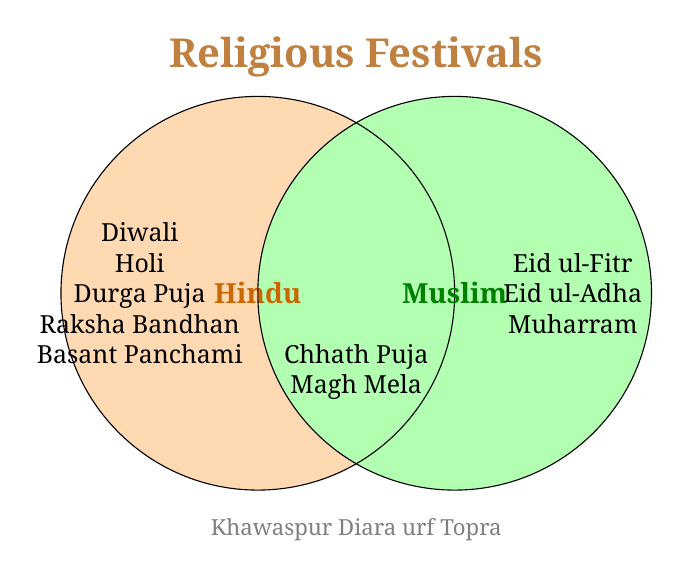What are the common religious festivals celebrated in the community? The common festivals appear in the area where the two circles intersect. This section contains "Chhath Puja" and "Magh Mela."
Answer: Chhath Puja, Magh Mela How many festivals are celebrated only by Hindus? The Hindu-only festivals are listed in the orange circle on the left. These are "Diwali," "Holi," "Durga Puja," "Raksha Bandhan," and "Basant Panchami."
Answer: 5 Which religious group celebrates "Eid ul-Fitr"? "Eid ul-Fitr" is listed in the green circle, which is attributed to Muslims.
Answer: Muslims Is "Raksha Bandhan" a common festival between Hindus and Muslims? "Raksha Bandhan" is located in the orange circle specific to Hindus and not in the overlapping area.
Answer: No How many festivals are celebrated exclusively by Muslims? The Muslim-only festivals are listed in the green circle on the right. These are "Eid ul-Fitr," "Eid ul-Adha," and "Muharram."
Answer: 3 Which religious festivals are unique and not shared by any other group? Unique festivals are those listed in either the Hindu or Muslim circles but not in the overlapping section. Hindu: "Diwali," "Holi," "Durga Puja," "Raksha Bandhan," "Basant Panchami." Muslim: "Eid ul-Fitr," "Eid ul-Adha," "Muharram."
Answer: Diwali, Holi, Durga Puja, Raksha Bandhan, Basant Panchami, Eid ul-Fitr, Eid ul-Adha, Muharram How many religious festivals in total are celebrated in the community? By counting all the festivals in both the Hindu and Muslim circles, including the common festivals, we get 10.
Answer: 10 Which Hindu festival is celebrated just before the start of the spring season? "Basant Panchami" is known to be celebrated just before the spring.
Answer: Basant Panchami Which religious festivals could you expect to be equally respected by neighbors of different religions in Khawaspur Diara urf Topra? The common festivals between Hindus and Muslims are those in the overlapping section of the diagram: "Chhath Puja" and "Magh Mela."
Answer: Chhath Puja, Magh Mela 